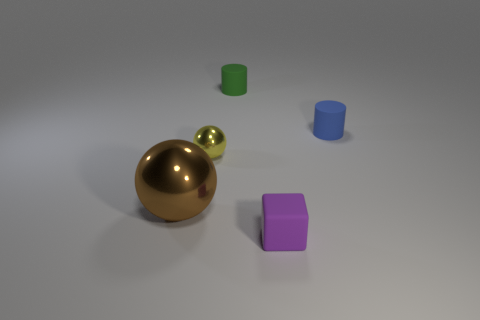Are there the same number of blue rubber cylinders that are on the right side of the blue cylinder and metallic things?
Provide a short and direct response. No. Is the material of the small green object the same as the yellow object?
Ensure brevity in your answer.  No. There is a rubber thing that is to the left of the blue object and in front of the green rubber cylinder; what size is it?
Offer a very short reply. Small. What number of other matte things have the same size as the brown thing?
Your answer should be compact. 0. There is a rubber object that is behind the tiny matte thing that is right of the purple rubber object; what is its size?
Your answer should be very brief. Small. Do the small rubber thing that is on the right side of the block and the tiny rubber thing that is on the left side of the purple matte block have the same shape?
Keep it short and to the point. Yes. The object that is both in front of the tiny yellow thing and right of the brown metal ball is what color?
Your answer should be compact. Purple. Is there a large metal block of the same color as the small shiny thing?
Your response must be concise. No. There is a metal ball that is in front of the small yellow thing; what color is it?
Ensure brevity in your answer.  Brown. Is there a blue cylinder on the left side of the matte cylinder on the right side of the tiny cube?
Make the answer very short. No. 